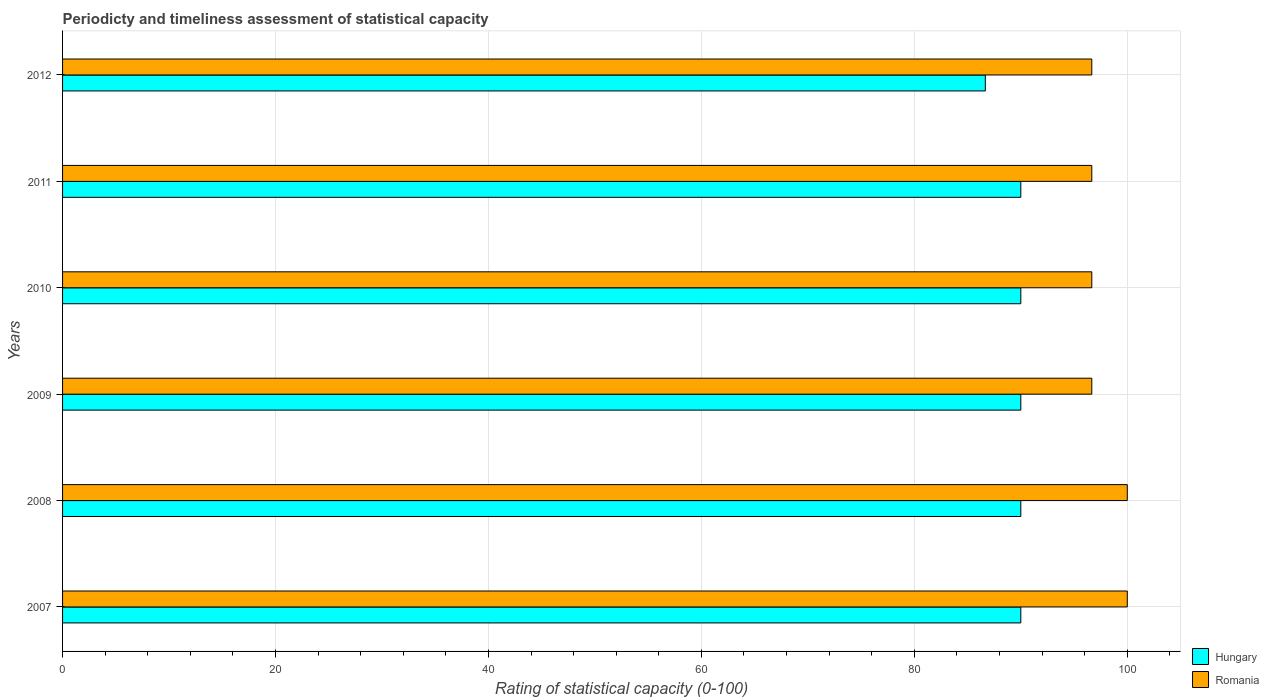Are the number of bars per tick equal to the number of legend labels?
Ensure brevity in your answer.  Yes. How many bars are there on the 1st tick from the bottom?
Offer a terse response. 2. What is the rating of statistical capacity in Romania in 2011?
Your response must be concise. 96.67. Across all years, what is the maximum rating of statistical capacity in Romania?
Your answer should be very brief. 100. Across all years, what is the minimum rating of statistical capacity in Romania?
Ensure brevity in your answer.  96.67. In which year was the rating of statistical capacity in Hungary maximum?
Offer a terse response. 2007. What is the total rating of statistical capacity in Romania in the graph?
Your response must be concise. 586.67. What is the difference between the rating of statistical capacity in Hungary in 2007 and that in 2012?
Provide a succinct answer. 3.33. What is the difference between the rating of statistical capacity in Hungary in 2010 and the rating of statistical capacity in Romania in 2009?
Make the answer very short. -6.67. What is the average rating of statistical capacity in Romania per year?
Give a very brief answer. 97.78. In the year 2010, what is the difference between the rating of statistical capacity in Hungary and rating of statistical capacity in Romania?
Keep it short and to the point. -6.67. What is the ratio of the rating of statistical capacity in Romania in 2009 to that in 2011?
Your response must be concise. 1. Is the rating of statistical capacity in Romania in 2007 less than that in 2009?
Provide a succinct answer. No. Is the difference between the rating of statistical capacity in Hungary in 2008 and 2011 greater than the difference between the rating of statistical capacity in Romania in 2008 and 2011?
Ensure brevity in your answer.  No. What is the difference between the highest and the second highest rating of statistical capacity in Romania?
Make the answer very short. 0. What is the difference between the highest and the lowest rating of statistical capacity in Hungary?
Your answer should be very brief. 3.33. In how many years, is the rating of statistical capacity in Hungary greater than the average rating of statistical capacity in Hungary taken over all years?
Keep it short and to the point. 5. Is the sum of the rating of statistical capacity in Hungary in 2011 and 2012 greater than the maximum rating of statistical capacity in Romania across all years?
Provide a succinct answer. Yes. What does the 1st bar from the top in 2012 represents?
Ensure brevity in your answer.  Romania. What does the 1st bar from the bottom in 2012 represents?
Your answer should be compact. Hungary. What is the difference between two consecutive major ticks on the X-axis?
Your response must be concise. 20. Where does the legend appear in the graph?
Make the answer very short. Bottom right. How are the legend labels stacked?
Your answer should be very brief. Vertical. What is the title of the graph?
Your response must be concise. Periodicty and timeliness assessment of statistical capacity. Does "Belgium" appear as one of the legend labels in the graph?
Provide a short and direct response. No. What is the label or title of the X-axis?
Offer a terse response. Rating of statistical capacity (0-100). What is the label or title of the Y-axis?
Offer a terse response. Years. What is the Rating of statistical capacity (0-100) in Hungary in 2007?
Offer a terse response. 90. What is the Rating of statistical capacity (0-100) of Hungary in 2008?
Offer a terse response. 90. What is the Rating of statistical capacity (0-100) of Romania in 2009?
Make the answer very short. 96.67. What is the Rating of statistical capacity (0-100) of Romania in 2010?
Make the answer very short. 96.67. What is the Rating of statistical capacity (0-100) of Hungary in 2011?
Ensure brevity in your answer.  90. What is the Rating of statistical capacity (0-100) in Romania in 2011?
Provide a succinct answer. 96.67. What is the Rating of statistical capacity (0-100) in Hungary in 2012?
Give a very brief answer. 86.67. What is the Rating of statistical capacity (0-100) in Romania in 2012?
Your response must be concise. 96.67. Across all years, what is the minimum Rating of statistical capacity (0-100) in Hungary?
Give a very brief answer. 86.67. Across all years, what is the minimum Rating of statistical capacity (0-100) of Romania?
Your answer should be very brief. 96.67. What is the total Rating of statistical capacity (0-100) in Hungary in the graph?
Your answer should be very brief. 536.67. What is the total Rating of statistical capacity (0-100) of Romania in the graph?
Offer a very short reply. 586.67. What is the difference between the Rating of statistical capacity (0-100) in Hungary in 2007 and that in 2008?
Offer a terse response. 0. What is the difference between the Rating of statistical capacity (0-100) in Romania in 2007 and that in 2008?
Ensure brevity in your answer.  0. What is the difference between the Rating of statistical capacity (0-100) of Romania in 2007 and that in 2010?
Your response must be concise. 3.33. What is the difference between the Rating of statistical capacity (0-100) in Hungary in 2007 and that in 2011?
Provide a short and direct response. 0. What is the difference between the Rating of statistical capacity (0-100) in Romania in 2007 and that in 2011?
Provide a succinct answer. 3.33. What is the difference between the Rating of statistical capacity (0-100) in Hungary in 2007 and that in 2012?
Provide a succinct answer. 3.33. What is the difference between the Rating of statistical capacity (0-100) of Romania in 2007 and that in 2012?
Provide a succinct answer. 3.33. What is the difference between the Rating of statistical capacity (0-100) of Hungary in 2008 and that in 2010?
Provide a succinct answer. 0. What is the difference between the Rating of statistical capacity (0-100) in Romania in 2008 and that in 2010?
Your answer should be very brief. 3.33. What is the difference between the Rating of statistical capacity (0-100) in Romania in 2008 and that in 2011?
Provide a succinct answer. 3.33. What is the difference between the Rating of statistical capacity (0-100) in Hungary in 2008 and that in 2012?
Your answer should be very brief. 3.33. What is the difference between the Rating of statistical capacity (0-100) of Hungary in 2009 and that in 2010?
Ensure brevity in your answer.  0. What is the difference between the Rating of statistical capacity (0-100) in Romania in 2009 and that in 2010?
Your response must be concise. 0. What is the difference between the Rating of statistical capacity (0-100) of Romania in 2009 and that in 2011?
Keep it short and to the point. 0. What is the difference between the Rating of statistical capacity (0-100) of Hungary in 2010 and that in 2011?
Keep it short and to the point. 0. What is the difference between the Rating of statistical capacity (0-100) in Romania in 2010 and that in 2011?
Provide a succinct answer. 0. What is the difference between the Rating of statistical capacity (0-100) in Romania in 2010 and that in 2012?
Your answer should be compact. 0. What is the difference between the Rating of statistical capacity (0-100) of Hungary in 2011 and that in 2012?
Your answer should be very brief. 3.33. What is the difference between the Rating of statistical capacity (0-100) of Hungary in 2007 and the Rating of statistical capacity (0-100) of Romania in 2009?
Provide a succinct answer. -6.67. What is the difference between the Rating of statistical capacity (0-100) in Hungary in 2007 and the Rating of statistical capacity (0-100) in Romania in 2010?
Provide a succinct answer. -6.67. What is the difference between the Rating of statistical capacity (0-100) in Hungary in 2007 and the Rating of statistical capacity (0-100) in Romania in 2011?
Your answer should be very brief. -6.67. What is the difference between the Rating of statistical capacity (0-100) of Hungary in 2007 and the Rating of statistical capacity (0-100) of Romania in 2012?
Provide a succinct answer. -6.67. What is the difference between the Rating of statistical capacity (0-100) in Hungary in 2008 and the Rating of statistical capacity (0-100) in Romania in 2009?
Make the answer very short. -6.67. What is the difference between the Rating of statistical capacity (0-100) in Hungary in 2008 and the Rating of statistical capacity (0-100) in Romania in 2010?
Make the answer very short. -6.67. What is the difference between the Rating of statistical capacity (0-100) in Hungary in 2008 and the Rating of statistical capacity (0-100) in Romania in 2011?
Provide a short and direct response. -6.67. What is the difference between the Rating of statistical capacity (0-100) of Hungary in 2008 and the Rating of statistical capacity (0-100) of Romania in 2012?
Provide a short and direct response. -6.67. What is the difference between the Rating of statistical capacity (0-100) in Hungary in 2009 and the Rating of statistical capacity (0-100) in Romania in 2010?
Make the answer very short. -6.67. What is the difference between the Rating of statistical capacity (0-100) of Hungary in 2009 and the Rating of statistical capacity (0-100) of Romania in 2011?
Keep it short and to the point. -6.67. What is the difference between the Rating of statistical capacity (0-100) of Hungary in 2009 and the Rating of statistical capacity (0-100) of Romania in 2012?
Provide a short and direct response. -6.67. What is the difference between the Rating of statistical capacity (0-100) in Hungary in 2010 and the Rating of statistical capacity (0-100) in Romania in 2011?
Provide a succinct answer. -6.67. What is the difference between the Rating of statistical capacity (0-100) in Hungary in 2010 and the Rating of statistical capacity (0-100) in Romania in 2012?
Ensure brevity in your answer.  -6.67. What is the difference between the Rating of statistical capacity (0-100) in Hungary in 2011 and the Rating of statistical capacity (0-100) in Romania in 2012?
Your answer should be very brief. -6.67. What is the average Rating of statistical capacity (0-100) of Hungary per year?
Give a very brief answer. 89.44. What is the average Rating of statistical capacity (0-100) of Romania per year?
Give a very brief answer. 97.78. In the year 2008, what is the difference between the Rating of statistical capacity (0-100) of Hungary and Rating of statistical capacity (0-100) of Romania?
Your response must be concise. -10. In the year 2009, what is the difference between the Rating of statistical capacity (0-100) in Hungary and Rating of statistical capacity (0-100) in Romania?
Offer a very short reply. -6.67. In the year 2010, what is the difference between the Rating of statistical capacity (0-100) of Hungary and Rating of statistical capacity (0-100) of Romania?
Give a very brief answer. -6.67. In the year 2011, what is the difference between the Rating of statistical capacity (0-100) of Hungary and Rating of statistical capacity (0-100) of Romania?
Provide a short and direct response. -6.67. In the year 2012, what is the difference between the Rating of statistical capacity (0-100) of Hungary and Rating of statistical capacity (0-100) of Romania?
Ensure brevity in your answer.  -10. What is the ratio of the Rating of statistical capacity (0-100) in Romania in 2007 to that in 2008?
Your answer should be very brief. 1. What is the ratio of the Rating of statistical capacity (0-100) of Romania in 2007 to that in 2009?
Your response must be concise. 1.03. What is the ratio of the Rating of statistical capacity (0-100) in Hungary in 2007 to that in 2010?
Give a very brief answer. 1. What is the ratio of the Rating of statistical capacity (0-100) of Romania in 2007 to that in 2010?
Ensure brevity in your answer.  1.03. What is the ratio of the Rating of statistical capacity (0-100) of Romania in 2007 to that in 2011?
Your answer should be very brief. 1.03. What is the ratio of the Rating of statistical capacity (0-100) of Romania in 2007 to that in 2012?
Offer a terse response. 1.03. What is the ratio of the Rating of statistical capacity (0-100) in Romania in 2008 to that in 2009?
Provide a short and direct response. 1.03. What is the ratio of the Rating of statistical capacity (0-100) of Hungary in 2008 to that in 2010?
Provide a short and direct response. 1. What is the ratio of the Rating of statistical capacity (0-100) of Romania in 2008 to that in 2010?
Keep it short and to the point. 1.03. What is the ratio of the Rating of statistical capacity (0-100) in Romania in 2008 to that in 2011?
Your answer should be very brief. 1.03. What is the ratio of the Rating of statistical capacity (0-100) of Hungary in 2008 to that in 2012?
Make the answer very short. 1.04. What is the ratio of the Rating of statistical capacity (0-100) of Romania in 2008 to that in 2012?
Make the answer very short. 1.03. What is the ratio of the Rating of statistical capacity (0-100) of Hungary in 2009 to that in 2010?
Your answer should be compact. 1. What is the ratio of the Rating of statistical capacity (0-100) of Hungary in 2009 to that in 2011?
Offer a terse response. 1. What is the ratio of the Rating of statistical capacity (0-100) of Hungary in 2009 to that in 2012?
Keep it short and to the point. 1.04. What is the ratio of the Rating of statistical capacity (0-100) of Hungary in 2010 to that in 2011?
Give a very brief answer. 1. What is the ratio of the Rating of statistical capacity (0-100) in Romania in 2010 to that in 2011?
Offer a terse response. 1. What is the ratio of the Rating of statistical capacity (0-100) in Hungary in 2010 to that in 2012?
Ensure brevity in your answer.  1.04. What is the ratio of the Rating of statistical capacity (0-100) of Romania in 2010 to that in 2012?
Keep it short and to the point. 1. What is the ratio of the Rating of statistical capacity (0-100) in Hungary in 2011 to that in 2012?
Provide a short and direct response. 1.04. What is the ratio of the Rating of statistical capacity (0-100) in Romania in 2011 to that in 2012?
Provide a succinct answer. 1. What is the difference between the highest and the second highest Rating of statistical capacity (0-100) in Romania?
Your response must be concise. 0. What is the difference between the highest and the lowest Rating of statistical capacity (0-100) in Hungary?
Provide a succinct answer. 3.33. 